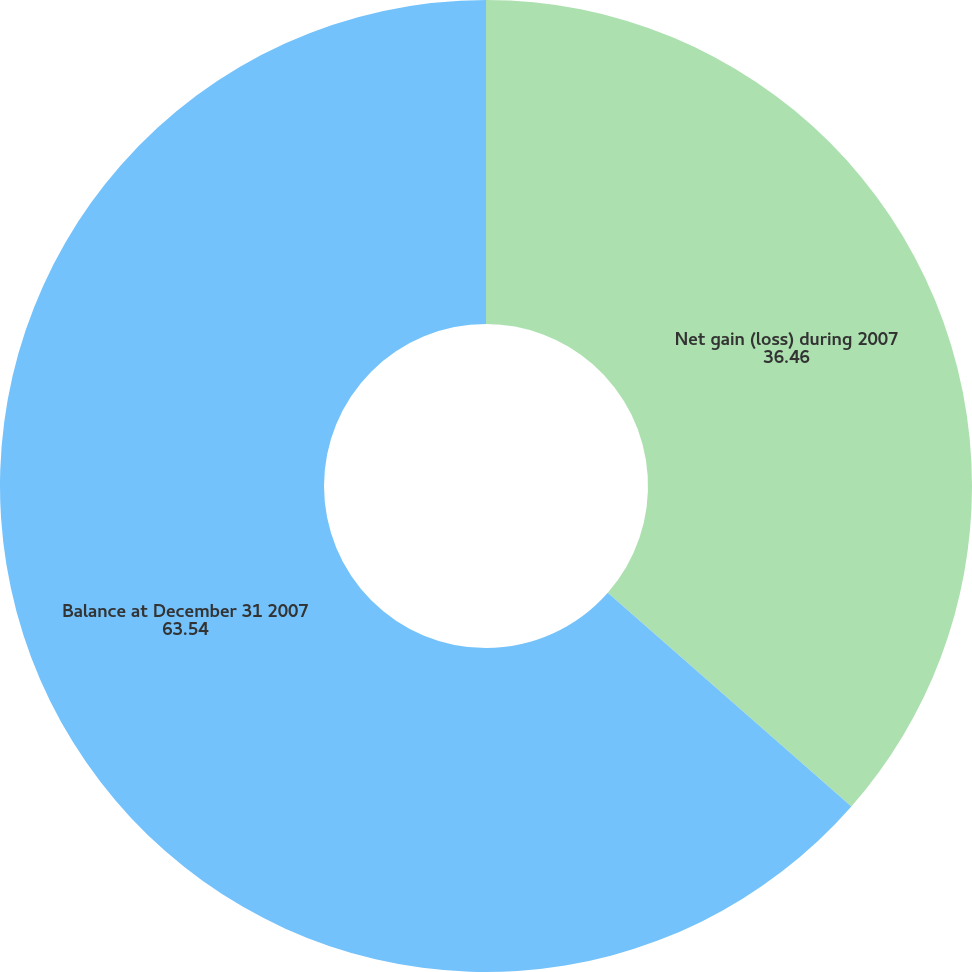Convert chart to OTSL. <chart><loc_0><loc_0><loc_500><loc_500><pie_chart><fcel>Net gain (loss) during 2007<fcel>Balance at December 31 2007<nl><fcel>36.46%<fcel>63.54%<nl></chart> 